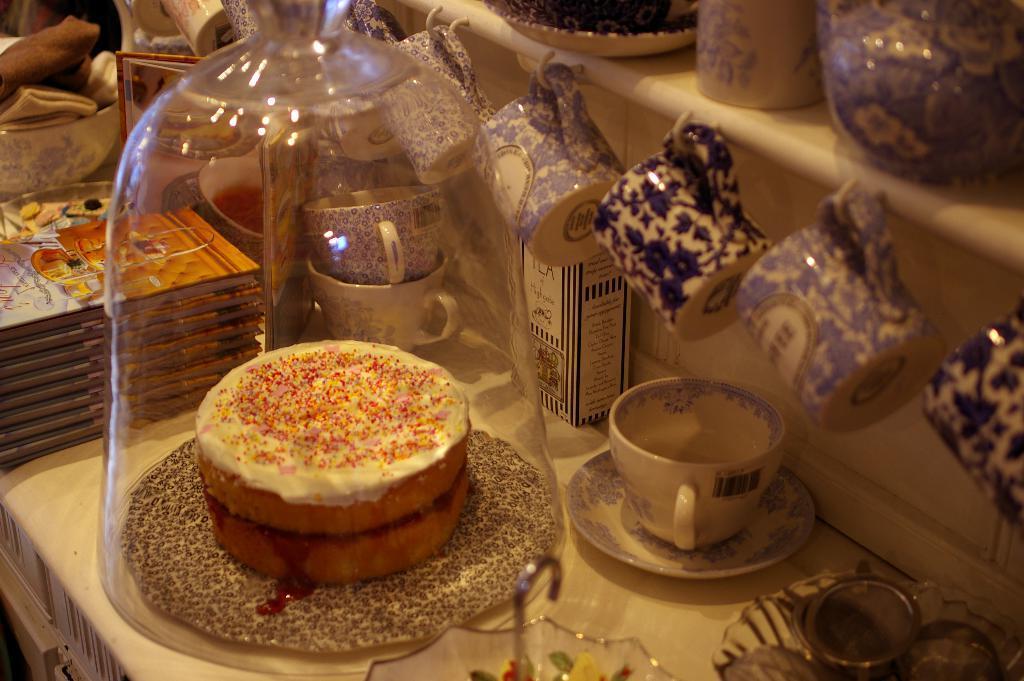How would you summarize this image in a sentence or two? In this picture there is a cream doughnut in the glass jar. Behind there are many blue color tea cups hanging on the hook. 